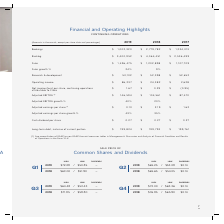According to Cubic's financial document, For the Adjusted EBITDA, where can the reconciliation of GAAP to non-GAAP financial measures tables be found? Management’s Discussion and Analysis of Financial Condition and Results of Operations in the Form 10-K. The document states: "of GAAP to non-GAAP financial measures tables in Management’s Discussion and Analysis of Financial Condition and Results of Operations in the Form 10-..." Also, What is the cash dividend per share in 2019? According to the financial document, $0.27. The relevant text states: "Cash dividend per share $ 0.27 $ 0.27 $ 0.27..." Also, What are the periods highlighted in the table? The document contains multiple relevant values: 2019, 2018, 2017. From the document: "except per share data and percentages) 2019 2018 2017 thousands, except per share data and percentages) 2019 2018 2017 ands, except per share data and..." Additionally, In which year is the adjusted earnings per share growth % larger? According to the financial document, 2019. The relevant text states: "thousands, except per share data and percentages) 2019 2018 2017..." Also, can you calculate: What is the change in the adjusted EBITDA growth % from 2018 to 2019? Based on the calculation: 40%-20%, the result is 20 (percentage). This is based on the information: "Adjusted EBITDA growth % 40% 20% Adjusted EBITDA growth % 40% 20%..." The key data points involved are: 40. Also, can you calculate: What is the percentage change in adjusted EBITDA in 2019 from 2018? To answer this question, I need to perform calculations using the financial data. The calculation is: (146,594-104,561)/104,561, which equals 40.2 (percentage). This is based on the information: "Adjusted EBITDA (1) $ 146,594 $ 104,561 $ 87,470 Adjusted EBITDA (1) $ 146,594 $ 104,561 $ 87,470..." The key data points involved are: 104,561, 146,594. 